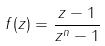Convert formula to latex. <formula><loc_0><loc_0><loc_500><loc_500>f ( z ) = \frac { z - 1 } { z ^ { n } - 1 }</formula> 